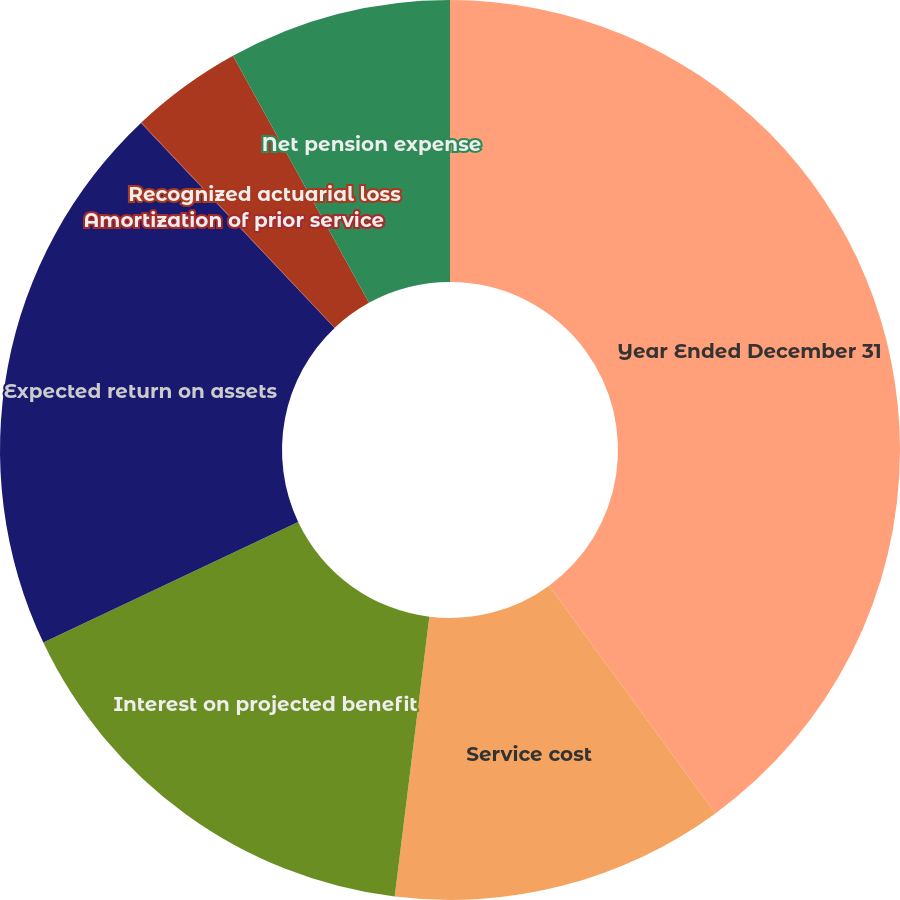Convert chart to OTSL. <chart><loc_0><loc_0><loc_500><loc_500><pie_chart><fcel>Year Ended December 31<fcel>Service cost<fcel>Interest on projected benefit<fcel>Expected return on assets<fcel>Amortization of prior service<fcel>Recognized actuarial loss<fcel>Net pension expense<nl><fcel>39.96%<fcel>12.0%<fcel>16.0%<fcel>19.99%<fcel>0.02%<fcel>4.02%<fcel>8.01%<nl></chart> 